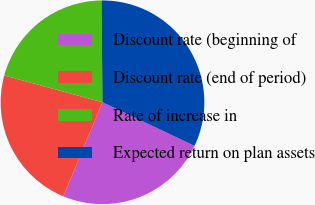Convert chart. <chart><loc_0><loc_0><loc_500><loc_500><pie_chart><fcel>Discount rate (beginning of<fcel>Discount rate (end of period)<fcel>Rate of increase in<fcel>Expected return on plan assets<nl><fcel>24.25%<fcel>22.96%<fcel>20.6%<fcel>32.19%<nl></chart> 